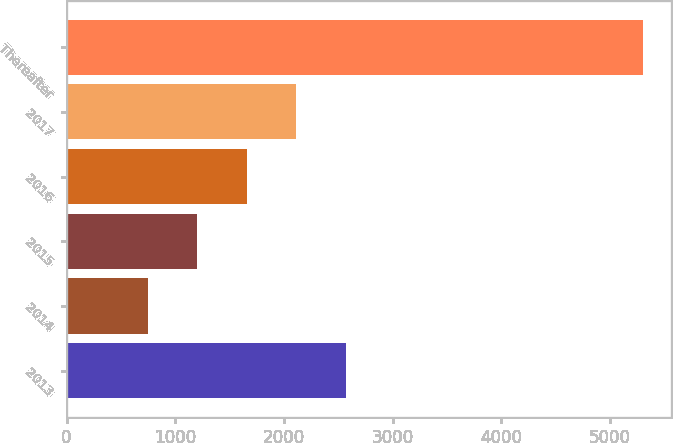<chart> <loc_0><loc_0><loc_500><loc_500><bar_chart><fcel>2013<fcel>2014<fcel>2015<fcel>2016<fcel>2017<fcel>Thereafter<nl><fcel>2569.4<fcel>749<fcel>1204.1<fcel>1659.2<fcel>2114.3<fcel>5300<nl></chart> 